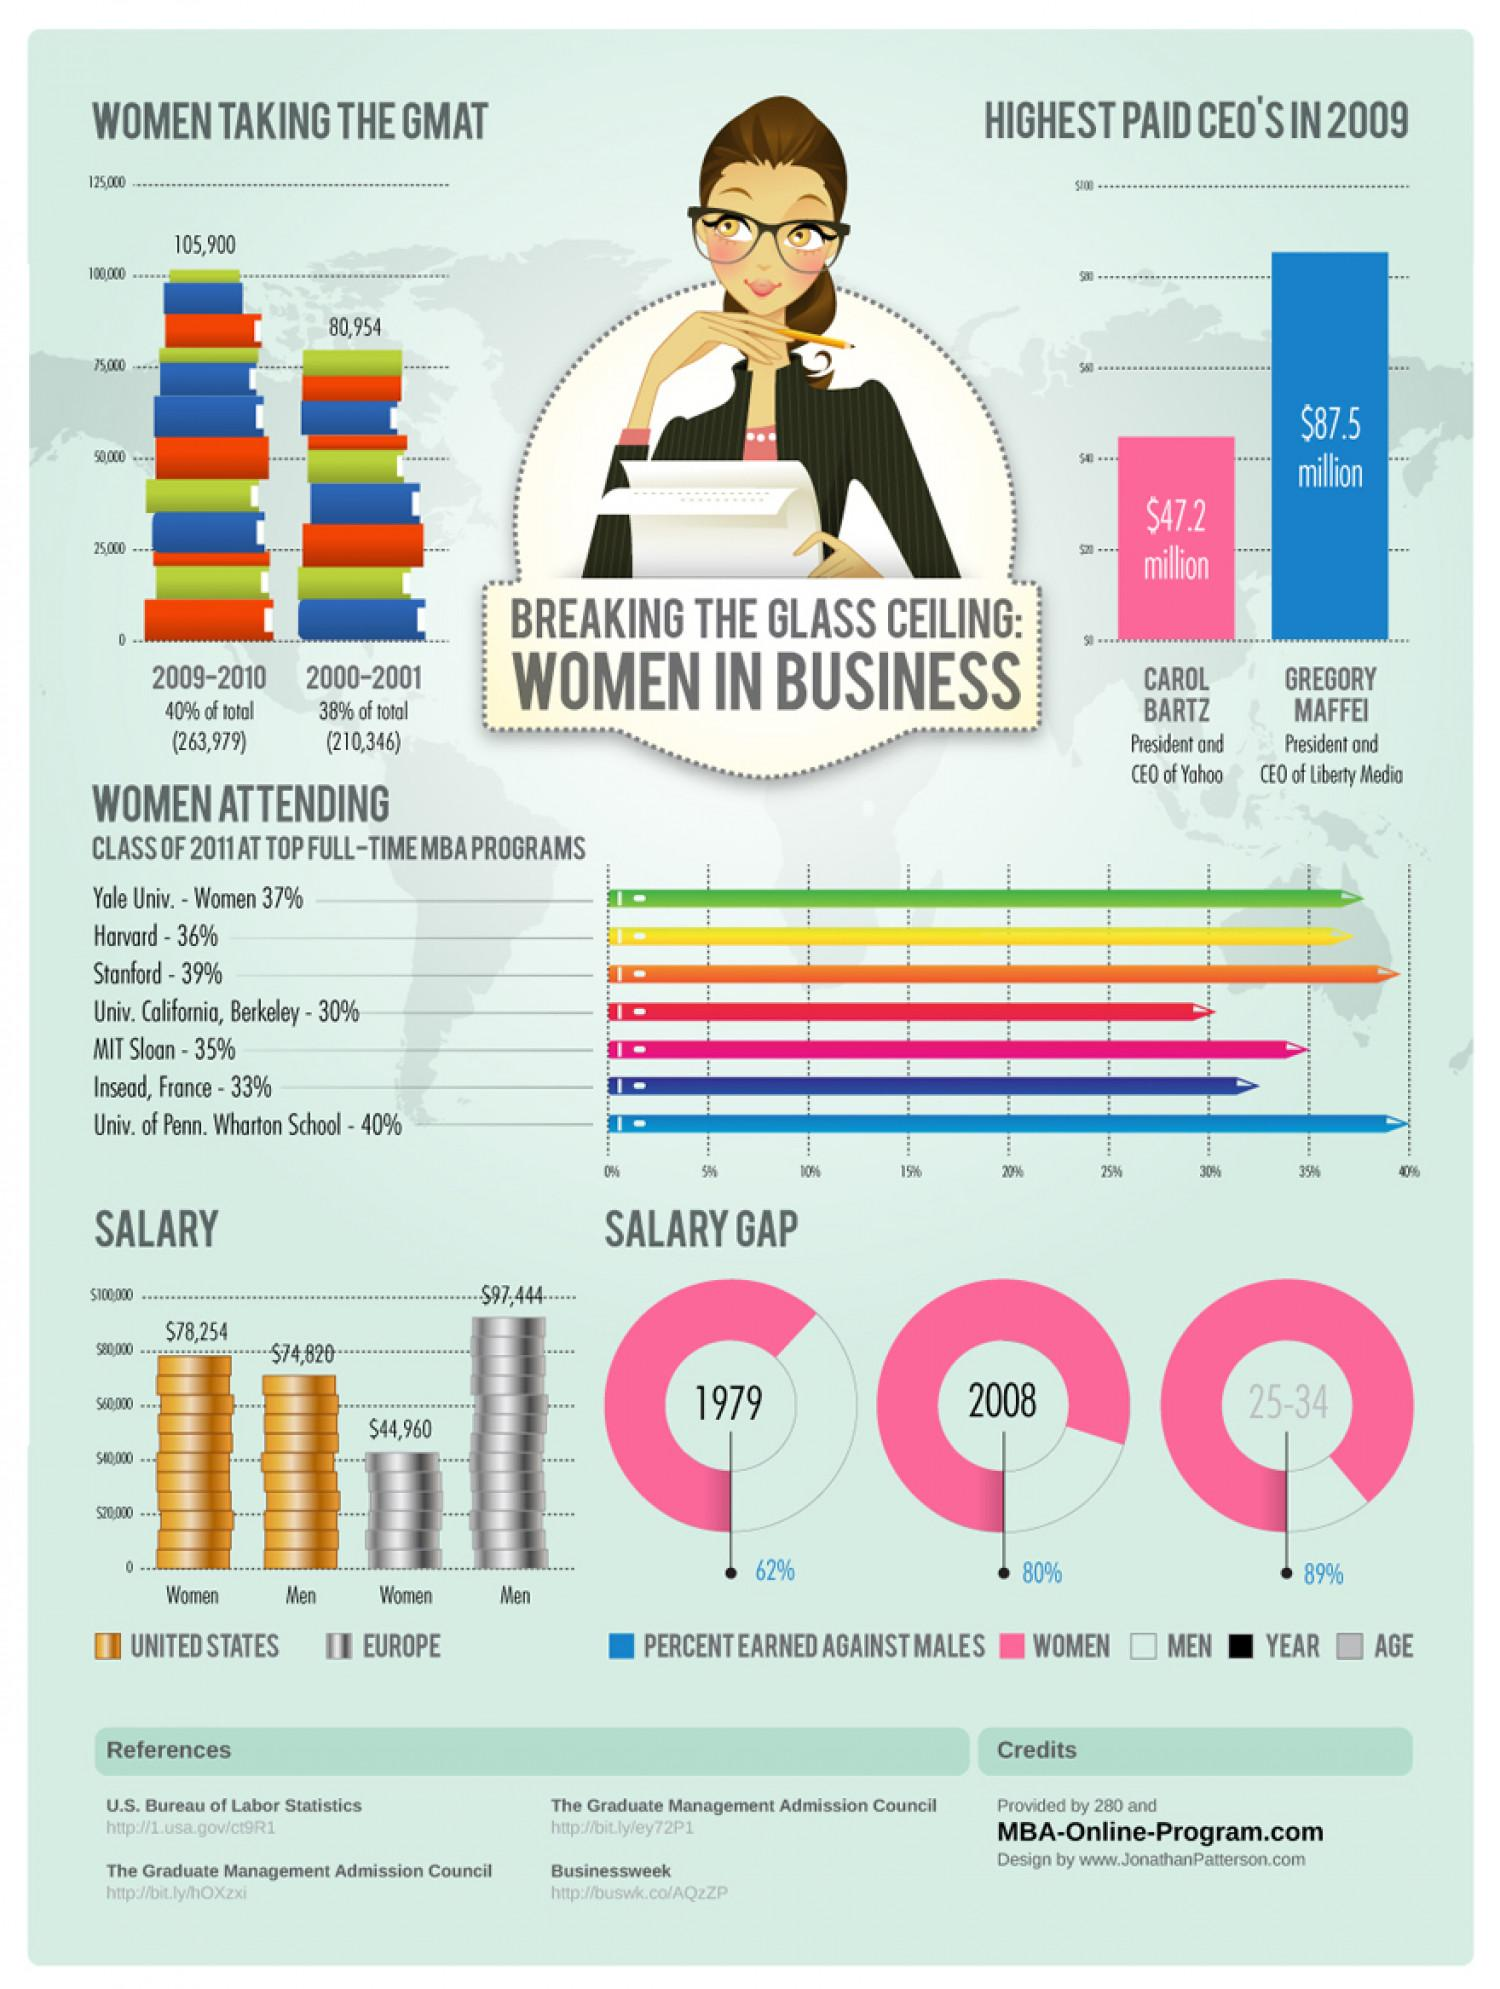Draw attention to some important aspects in this diagram. The percentage of women attending the class of 2011 at both MIT Sloan and Stanford's top full-time MBA programs is 74%. The percentage of women who took the Graduate Management Admission Test (GMAT) in 2009-2010 and 2000-2001 was 2%. The salary difference between men in Europe and the United States is $22,624. The salary difference between women in the United States and Europe is $33,294. The percentage of women attending the class of 2011 at the top full-time MBA programs at Harvard and Stanford, taken together, was 75%. 